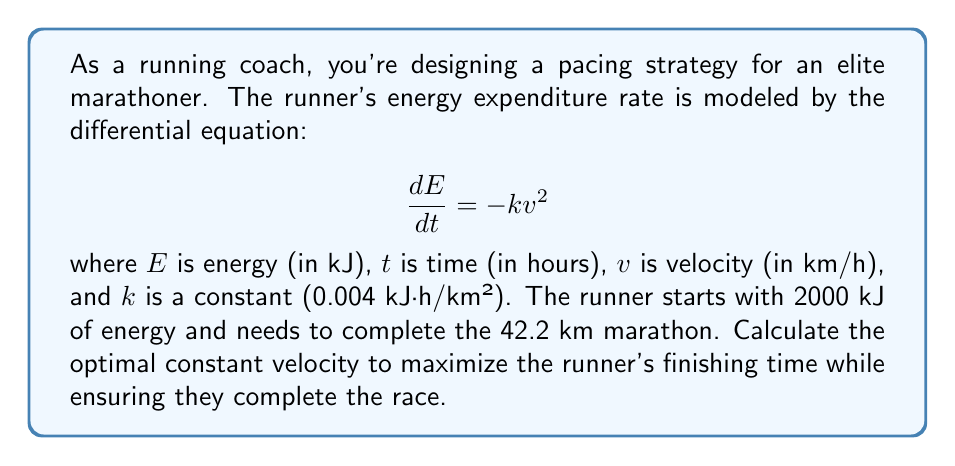Can you solve this math problem? 1) First, we need to express distance in terms of velocity and time:
   $$d = vt$$
   where $d$ is distance (42.2 km), $v$ is velocity, and $t$ is time.

2) Now, we can express time in terms of distance and velocity:
   $$t = \frac{d}{v} = \frac{42.2}{v}$$

3) We know that energy expenditure is given by:
   $$\frac{dE}{dt} = -kv^2$$

4) Integrating both sides with respect to time:
   $$\int_{E_0}^{E_f} dE = -k \int_0^t v^2 dt$$
   $$E_f - E_0 = -kv^2t$$

5) We want the runner to use all their energy, so $E_f = 0$ and $E_0 = 2000$:
   $$0 - 2000 = -kv^2t$$
   $$2000 = kv^2t$$

6) Substituting $t = \frac{42.2}{v}$ and $k = 0.004$:
   $$2000 = 0.004 \cdot v^2 \cdot \frac{42.2}{v}$$
   $$2000 = 0.1688v$$

7) Solving for $v$:
   $$v = \frac{2000}{0.1688} \approx 11.85 \text{ km/h}$$

8) To verify, we can calculate the time:
   $$t = \frac{42.2}{11.85} \approx 3.56 \text{ hours}$$

This is a reasonable marathon time for an elite runner.
Answer: 11.85 km/h 